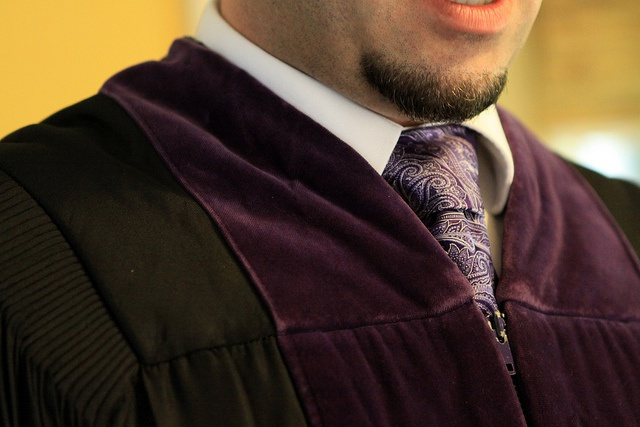Describe the objects in this image and their specific colors. I can see people in black, gold, maroon, and brown tones and tie in gold, black, gray, darkgray, and lightpink tones in this image. 